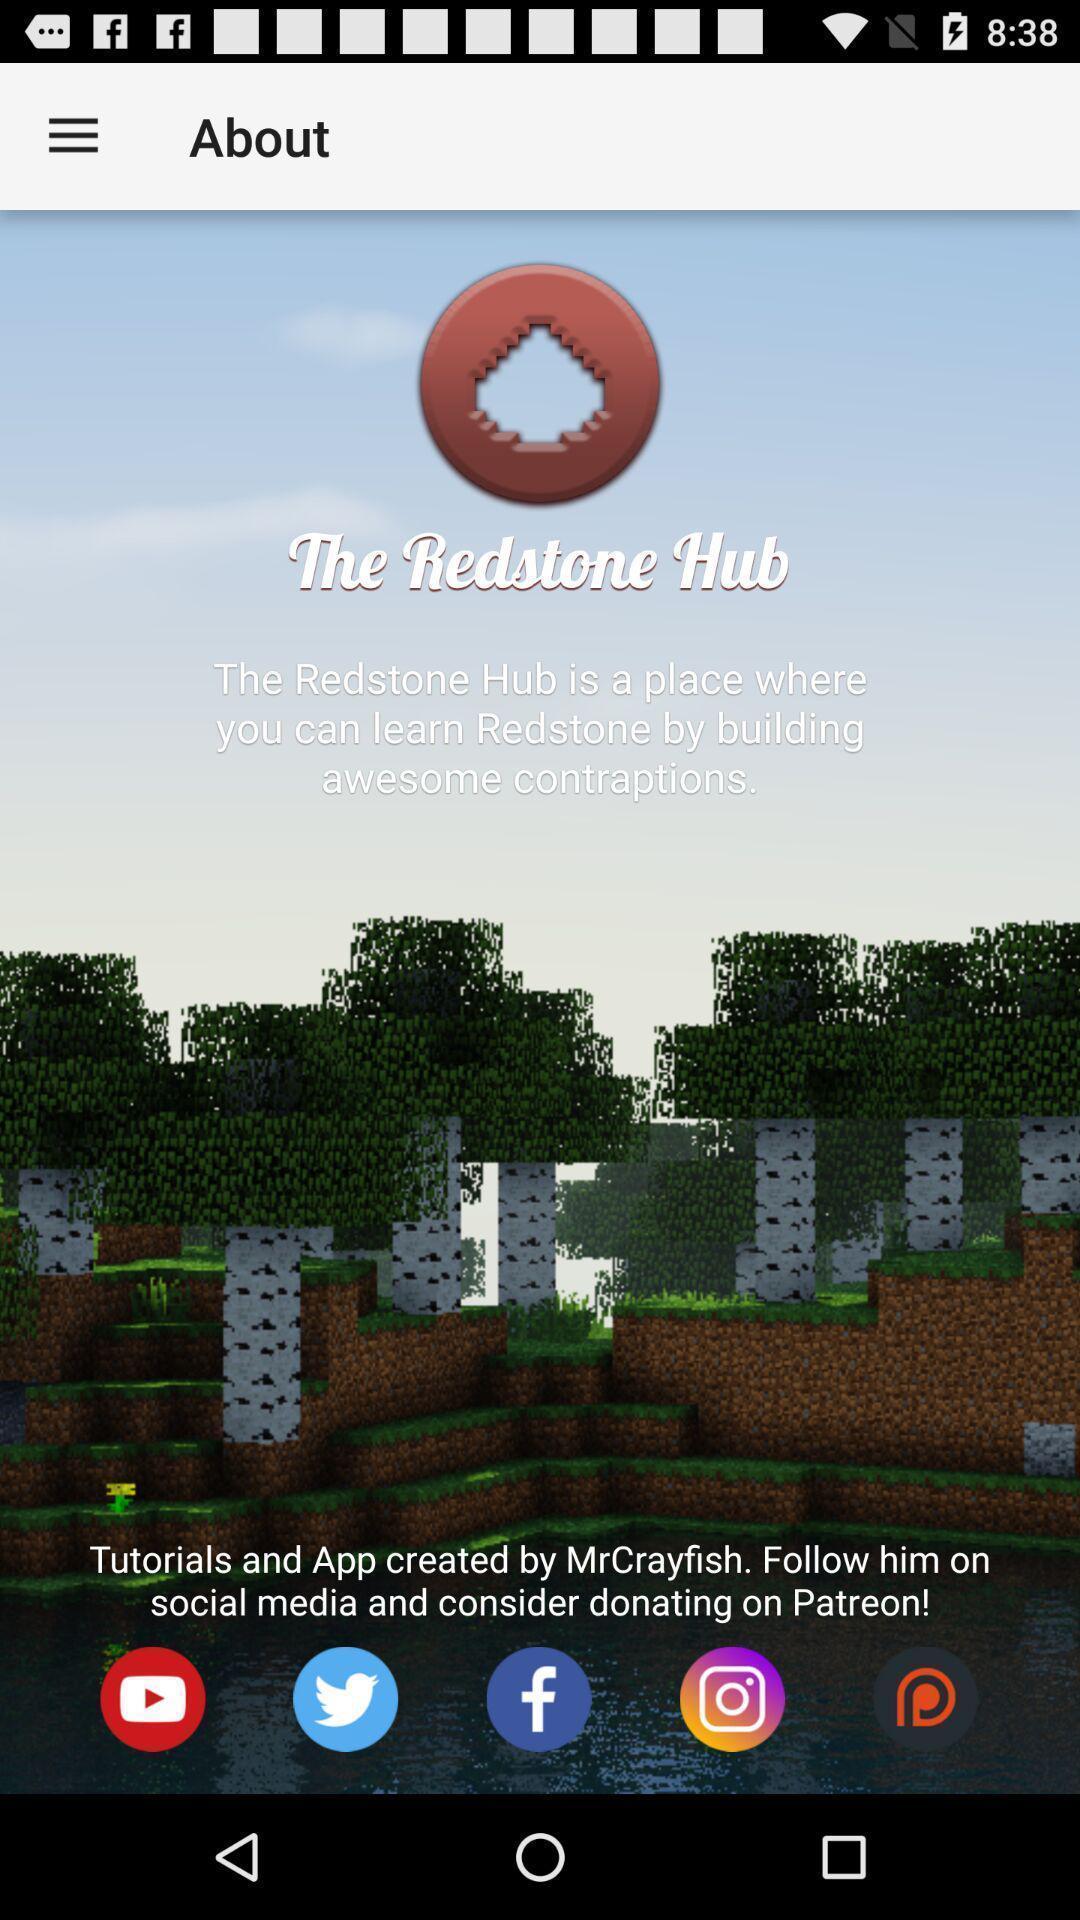Give me a narrative description of this picture. Screen showing welcome page. 